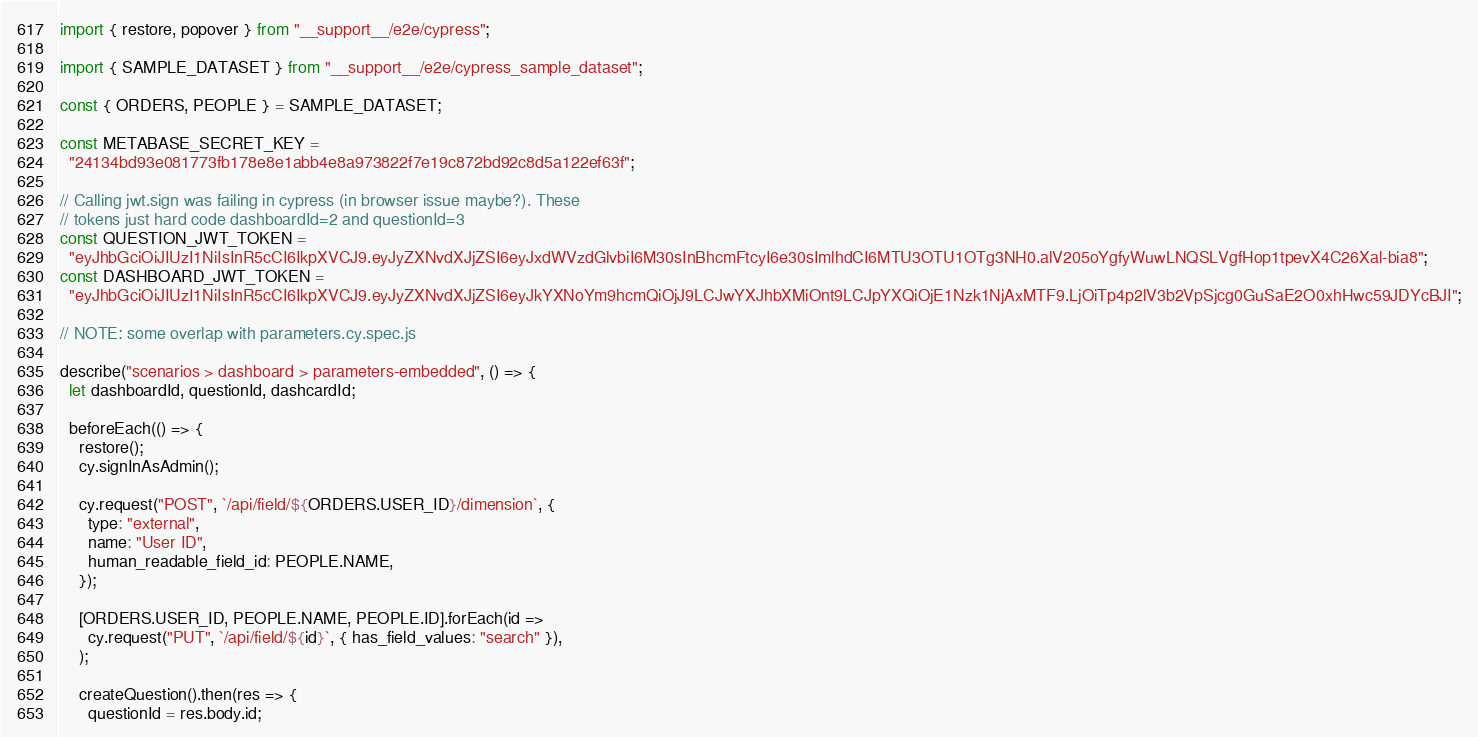<code> <loc_0><loc_0><loc_500><loc_500><_JavaScript_>import { restore, popover } from "__support__/e2e/cypress";

import { SAMPLE_DATASET } from "__support__/e2e/cypress_sample_dataset";

const { ORDERS, PEOPLE } = SAMPLE_DATASET;

const METABASE_SECRET_KEY =
  "24134bd93e081773fb178e8e1abb4e8a973822f7e19c872bd92c8d5a122ef63f";

// Calling jwt.sign was failing in cypress (in browser issue maybe?). These
// tokens just hard code dashboardId=2 and questionId=3
const QUESTION_JWT_TOKEN =
  "eyJhbGciOiJIUzI1NiIsInR5cCI6IkpXVCJ9.eyJyZXNvdXJjZSI6eyJxdWVzdGlvbiI6M30sInBhcmFtcyI6e30sImlhdCI6MTU3OTU1OTg3NH0.alV205oYgfyWuwLNQSLVgfHop1tpevX4C26Xal-bia8";
const DASHBOARD_JWT_TOKEN =
  "eyJhbGciOiJIUzI1NiIsInR5cCI6IkpXVCJ9.eyJyZXNvdXJjZSI6eyJkYXNoYm9hcmQiOjJ9LCJwYXJhbXMiOnt9LCJpYXQiOjE1Nzk1NjAxMTF9.LjOiTp4p2lV3b2VpSjcg0GuSaE2O0xhHwc59JDYcBJI";

// NOTE: some overlap with parameters.cy.spec.js

describe("scenarios > dashboard > parameters-embedded", () => {
  let dashboardId, questionId, dashcardId;

  beforeEach(() => {
    restore();
    cy.signInAsAdmin();

    cy.request("POST", `/api/field/${ORDERS.USER_ID}/dimension`, {
      type: "external",
      name: "User ID",
      human_readable_field_id: PEOPLE.NAME,
    });

    [ORDERS.USER_ID, PEOPLE.NAME, PEOPLE.ID].forEach(id =>
      cy.request("PUT", `/api/field/${id}`, { has_field_values: "search" }),
    );

    createQuestion().then(res => {
      questionId = res.body.id;</code> 